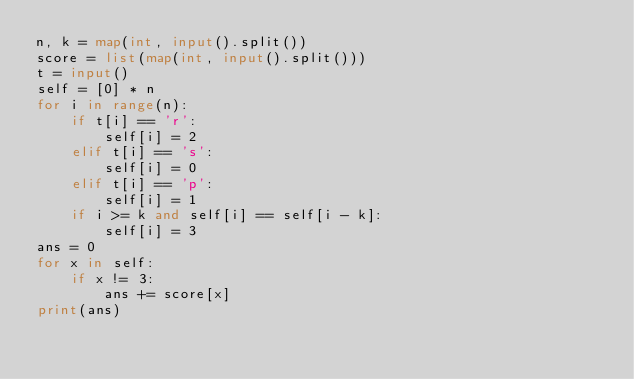<code> <loc_0><loc_0><loc_500><loc_500><_Python_>n, k = map(int, input().split())
score = list(map(int, input().split()))
t = input()
self = [0] * n
for i in range(n):
    if t[i] == 'r':
        self[i] = 2
    elif t[i] == 's':
        self[i] = 0
    elif t[i] == 'p':
        self[i] = 1
    if i >= k and self[i] == self[i - k]:
        self[i] = 3
ans = 0
for x in self:
    if x != 3:
        ans += score[x]
print(ans)
</code> 